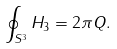Convert formula to latex. <formula><loc_0><loc_0><loc_500><loc_500>\oint _ { { S } ^ { 3 } } H _ { 3 } = 2 \pi Q .</formula> 